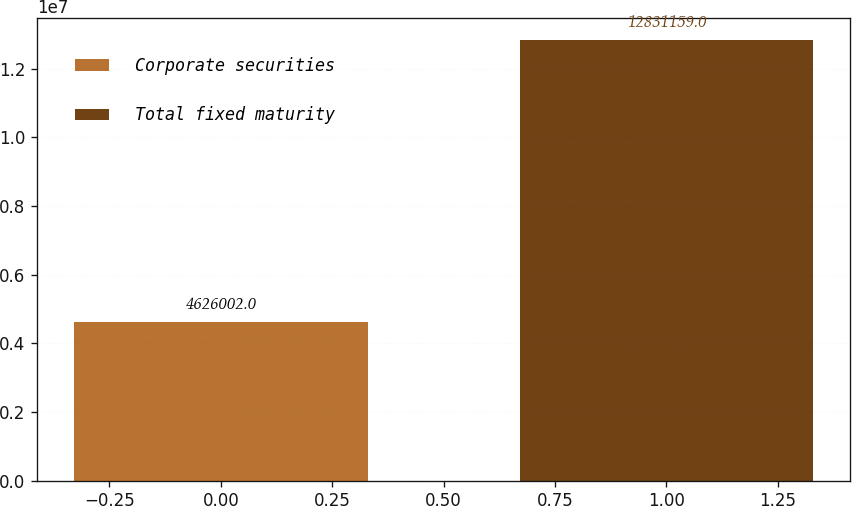Convert chart. <chart><loc_0><loc_0><loc_500><loc_500><bar_chart><fcel>Corporate securities<fcel>Total fixed maturity<nl><fcel>4.626e+06<fcel>1.28312e+07<nl></chart> 